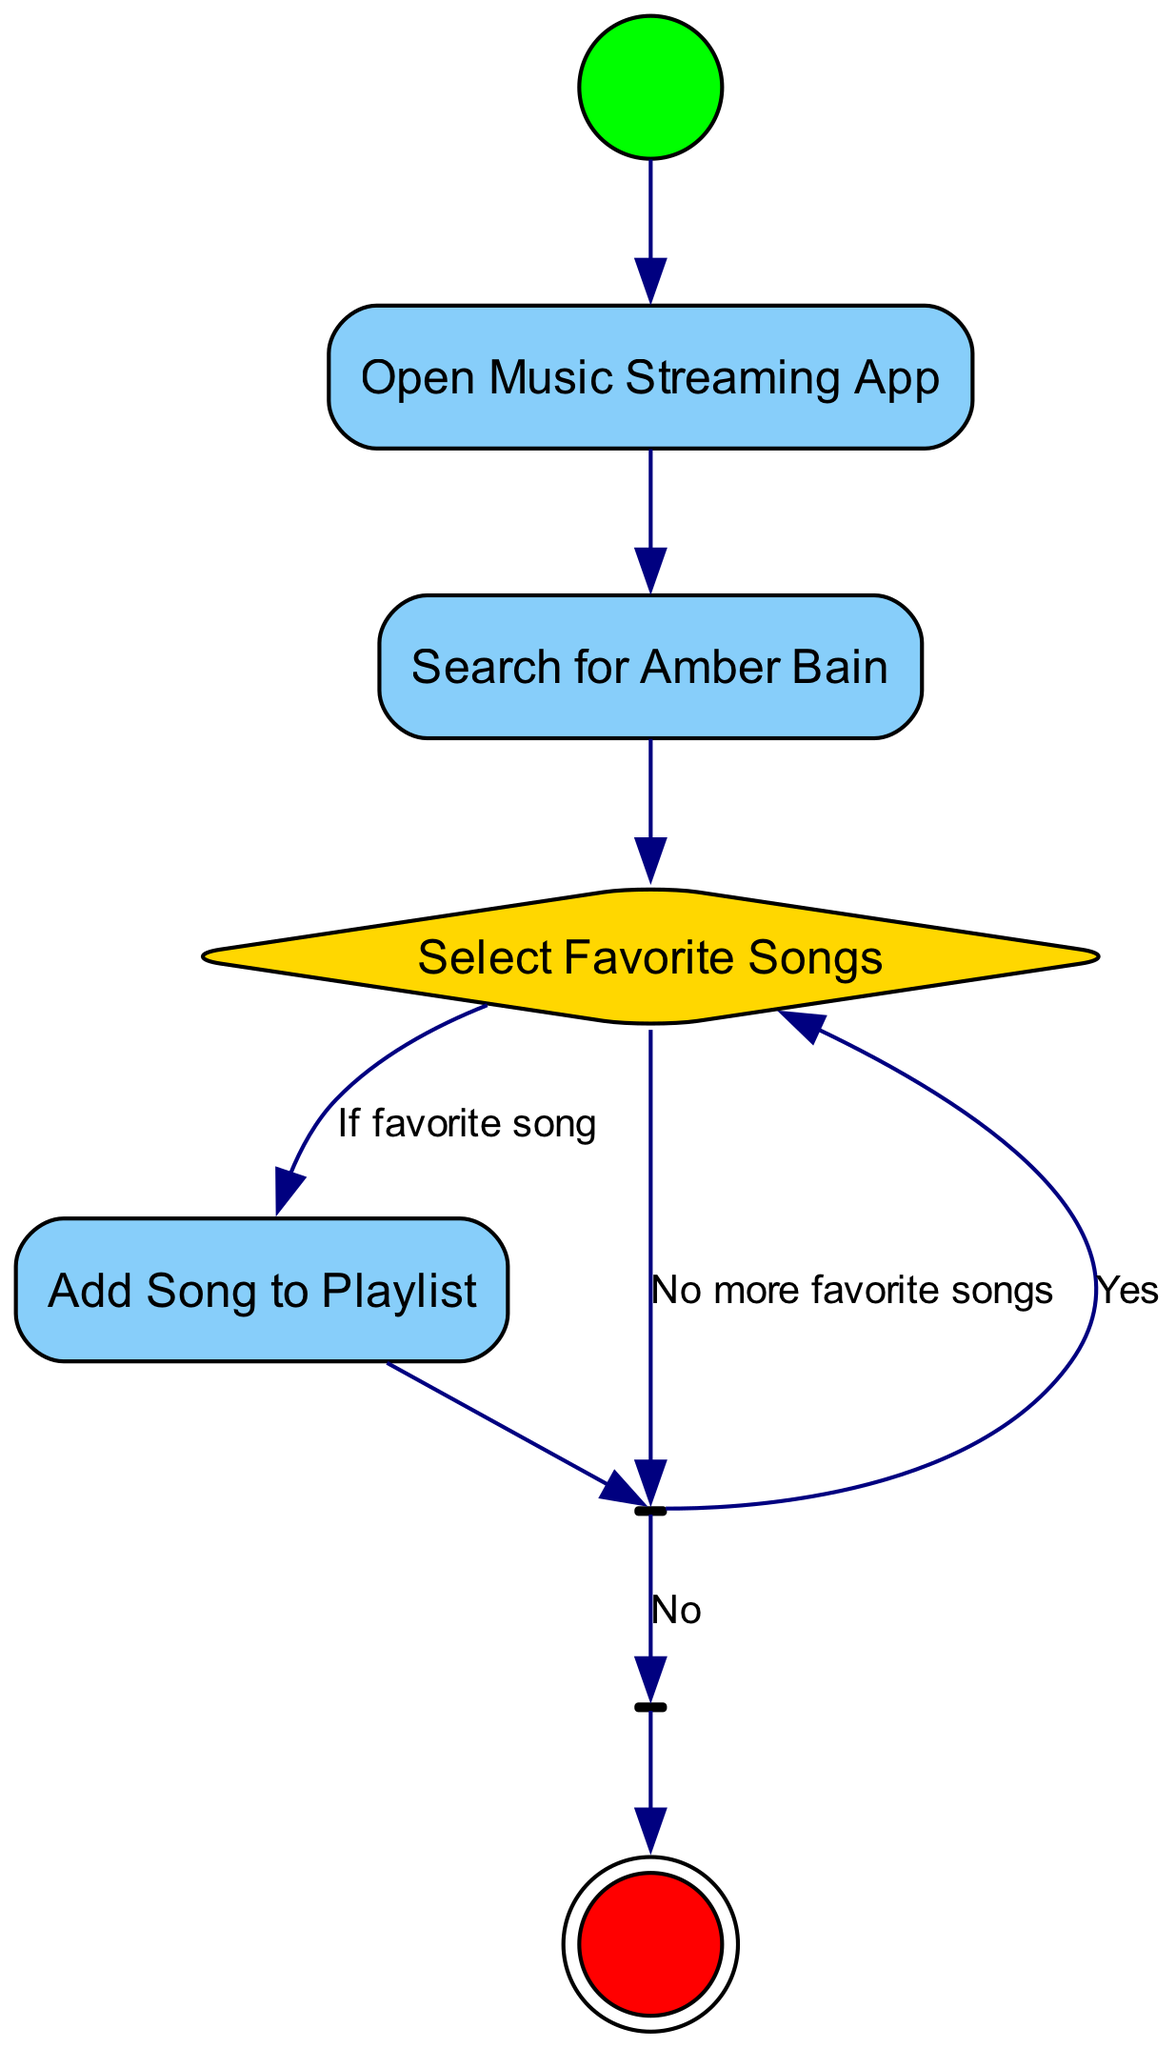What is the first action taken in the diagram? The diagram starts with the "Start" node, which leads to the first action node labeled "Open Music Streaming App". Therefore, the first action is "Open Music Streaming App".
Answer: Open Music Streaming App How many nodes are in the diagram? The diagram consists of 8 nodes: 1 StartNode, 1 FinalNode, 1 DecisionNode, 2 ActionNodes, and 2 special nodes (ForkNode and JoinNode). Adding them up gives a total of 8 nodes.
Answer: 8 What happens after selecting a favorite song? After selecting a favorite song, the next action is to "Add Song to Playlist". This is the direct edge from the "Choose Favorite Songs" decision node to the "Add Song to Playlist" action node.
Answer: Add Song to Playlist What is represented by the "Join" node in the diagram? The "Join" node, labeled "All Favorite Songs Added", signifies that previous processes or actions (in this case, adding songs) are complete before proceeding to the end of the diagram.
Answer: All Favorite Songs Added What decision must be made after adding a song to the playlist? After adding a song to the playlist, the next step is a decision represented by the "ForkChoices" node where the question is "Continue Adding Songs?". This determines whether to add more songs or stop.
Answer: Continue Adding Songs? 